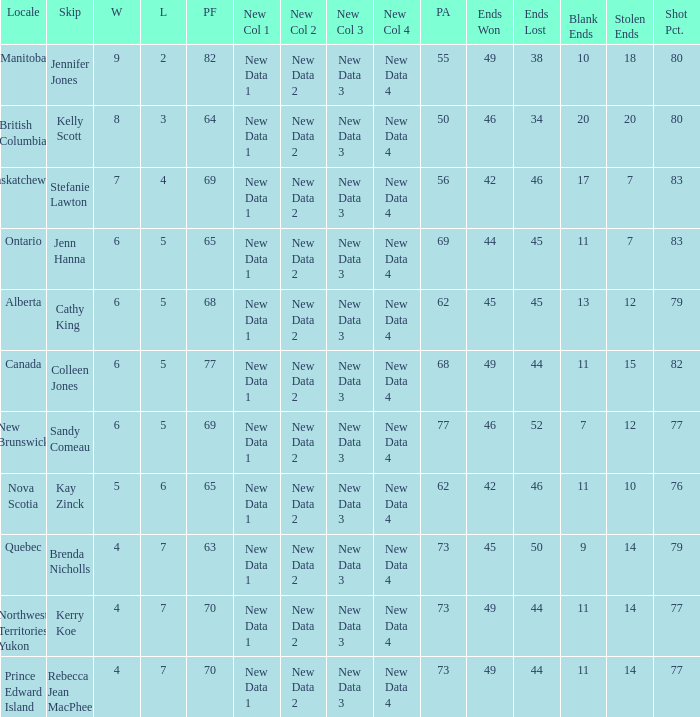What is the lowest PF? 63.0. 